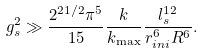Convert formula to latex. <formula><loc_0><loc_0><loc_500><loc_500>g _ { s } ^ { 2 } \gg \frac { 2 ^ { 2 1 / 2 } \pi ^ { 5 } } { 1 5 } \frac { k } { k _ { \max } } \frac { l _ { s } ^ { 1 2 } } { r _ { i n i } ^ { 6 } R ^ { 6 } } .</formula> 